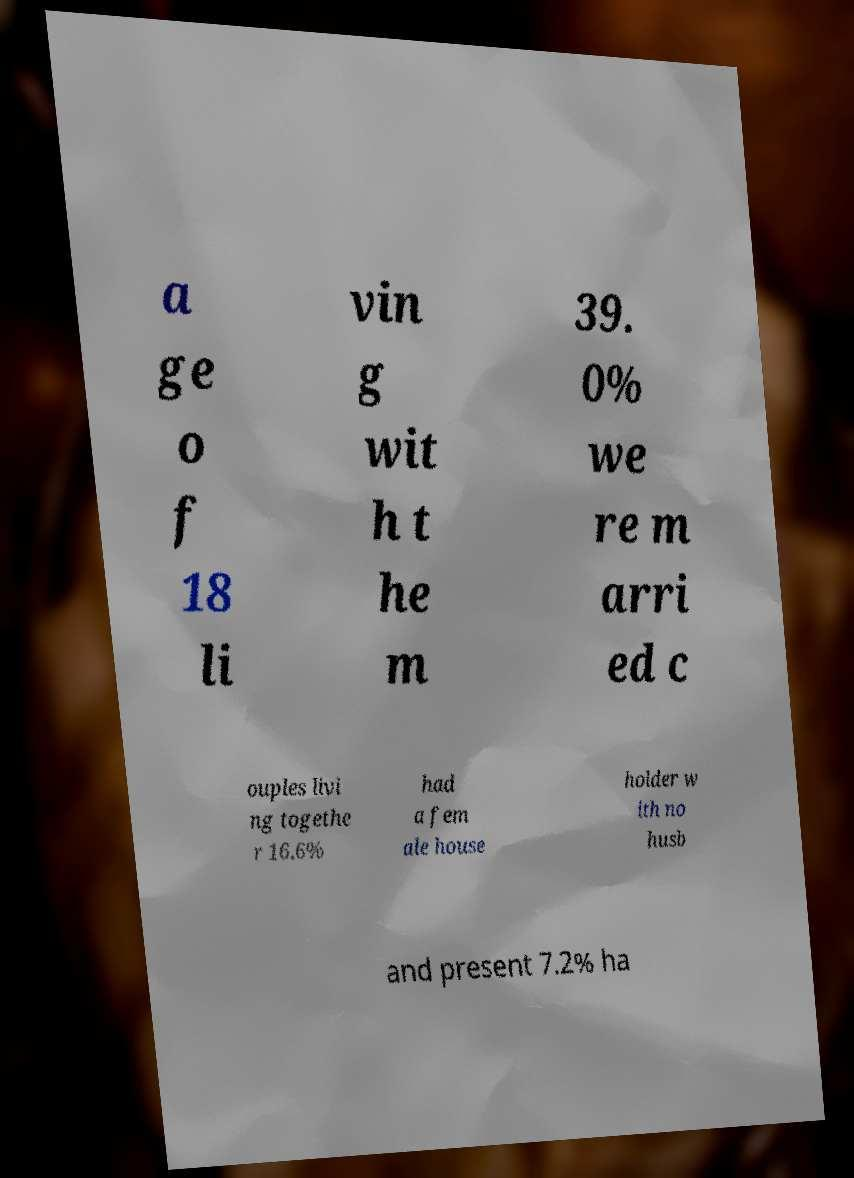What messages or text are displayed in this image? I need them in a readable, typed format. a ge o f 18 li vin g wit h t he m 39. 0% we re m arri ed c ouples livi ng togethe r 16.6% had a fem ale house holder w ith no husb and present 7.2% ha 